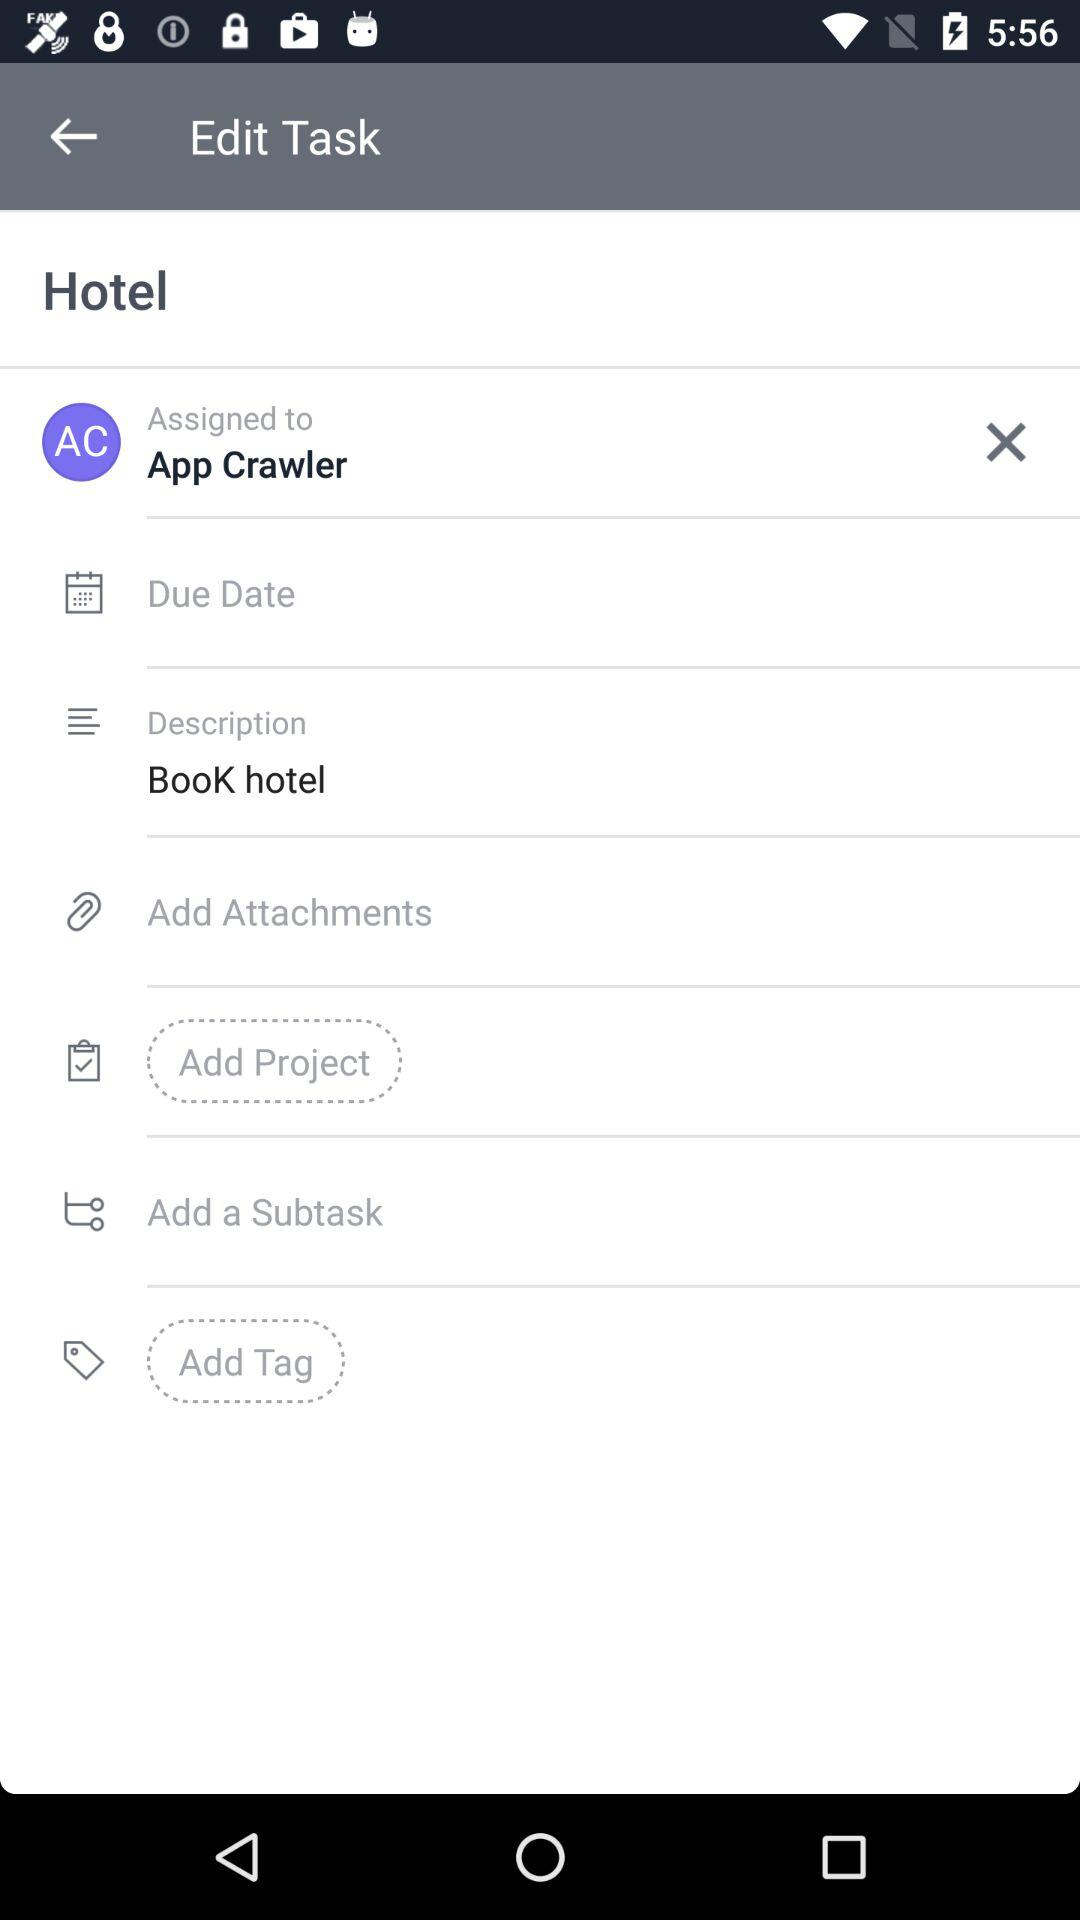The task is assigned to whom? The task has been assigned to App Crawler. 